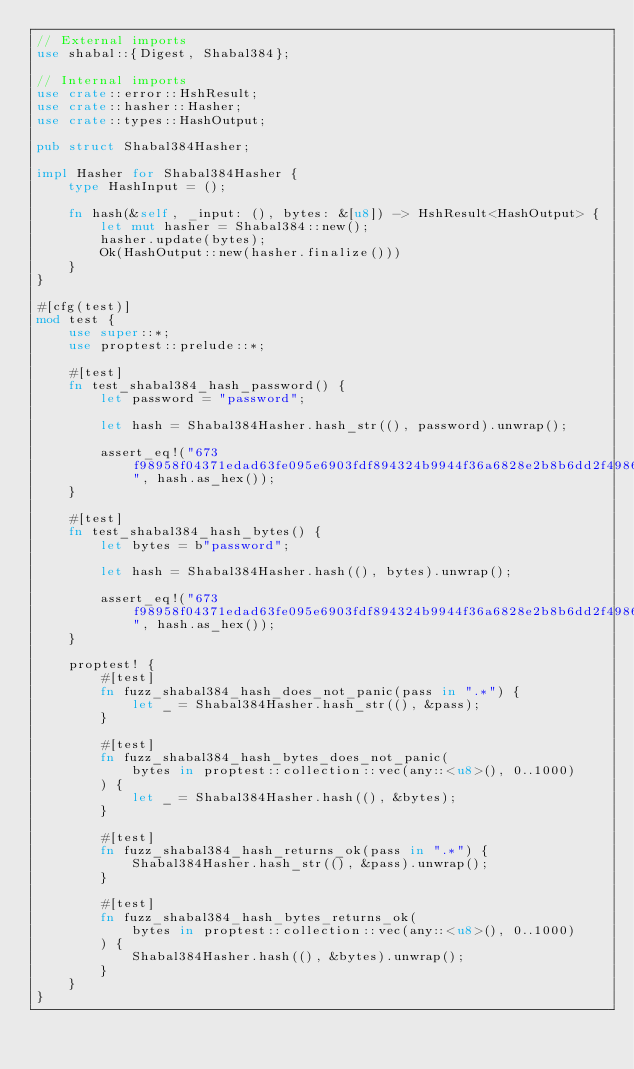Convert code to text. <code><loc_0><loc_0><loc_500><loc_500><_Rust_>// External imports
use shabal::{Digest, Shabal384};

// Internal imports
use crate::error::HshResult;
use crate::hasher::Hasher;
use crate::types::HashOutput;

pub struct Shabal384Hasher;

impl Hasher for Shabal384Hasher {
    type HashInput = ();

    fn hash(&self, _input: (), bytes: &[u8]) -> HshResult<HashOutput> {
        let mut hasher = Shabal384::new();
        hasher.update(bytes);
        Ok(HashOutput::new(hasher.finalize()))
    }
}

#[cfg(test)]
mod test {
    use super::*;
    use proptest::prelude::*;

    #[test]
    fn test_shabal384_hash_password() {
        let password = "password";

        let hash = Shabal384Hasher.hash_str((), password).unwrap();

        assert_eq!("673f98958f04371edad63fe095e6903fdf894324b9944f36a6828e2b8b6dd2f4986cd4a61e29bf2866f021bbbaa02e8a", hash.as_hex());
    }

    #[test]
    fn test_shabal384_hash_bytes() {
        let bytes = b"password";

        let hash = Shabal384Hasher.hash((), bytes).unwrap();

        assert_eq!("673f98958f04371edad63fe095e6903fdf894324b9944f36a6828e2b8b6dd2f4986cd4a61e29bf2866f021bbbaa02e8a", hash.as_hex());
    }

    proptest! {
        #[test]
        fn fuzz_shabal384_hash_does_not_panic(pass in ".*") {
            let _ = Shabal384Hasher.hash_str((), &pass);
        }

        #[test]
        fn fuzz_shabal384_hash_bytes_does_not_panic(
            bytes in proptest::collection::vec(any::<u8>(), 0..1000)
        ) {
            let _ = Shabal384Hasher.hash((), &bytes);
        }

        #[test]
        fn fuzz_shabal384_hash_returns_ok(pass in ".*") {
            Shabal384Hasher.hash_str((), &pass).unwrap();
        }

        #[test]
        fn fuzz_shabal384_hash_bytes_returns_ok(
            bytes in proptest::collection::vec(any::<u8>(), 0..1000)
        ) {
            Shabal384Hasher.hash((), &bytes).unwrap();
        }
    }
}
</code> 